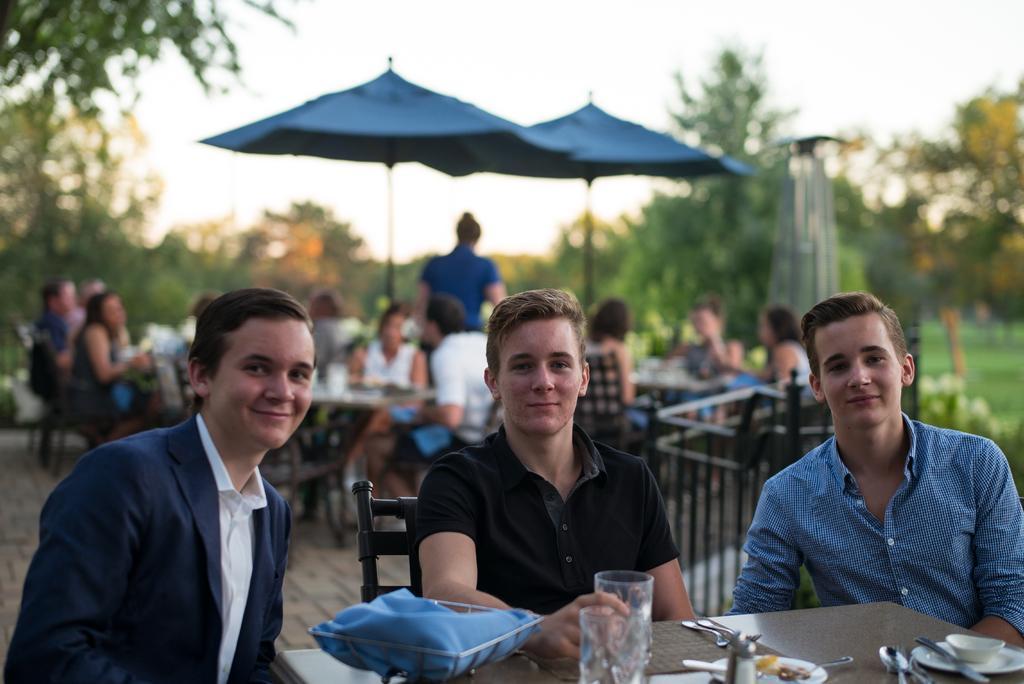In one or two sentences, can you explain what this image depicts? In this image, there are three persons sitting in front of the table. This table contains glasses spoons and plates. There are some trees behind these persons. There is sky and two umbrellas at the top of the image. 